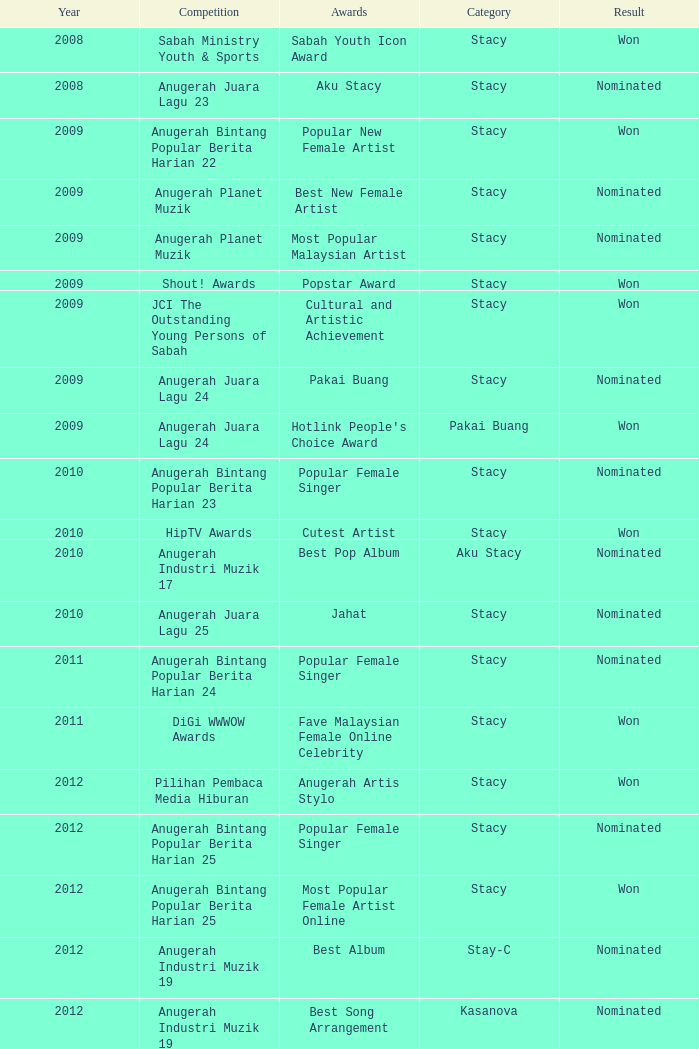What was the consequence in the stacy category with a jahat award for the years later than 2008? Nominated. 